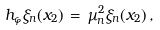<formula> <loc_0><loc_0><loc_500><loc_500>h _ { \varphi } \xi _ { n } ( x _ { 2 } ) \, = \, \mu _ { n } ^ { 2 } \xi _ { n } ( x _ { 2 } ) \, ,</formula> 